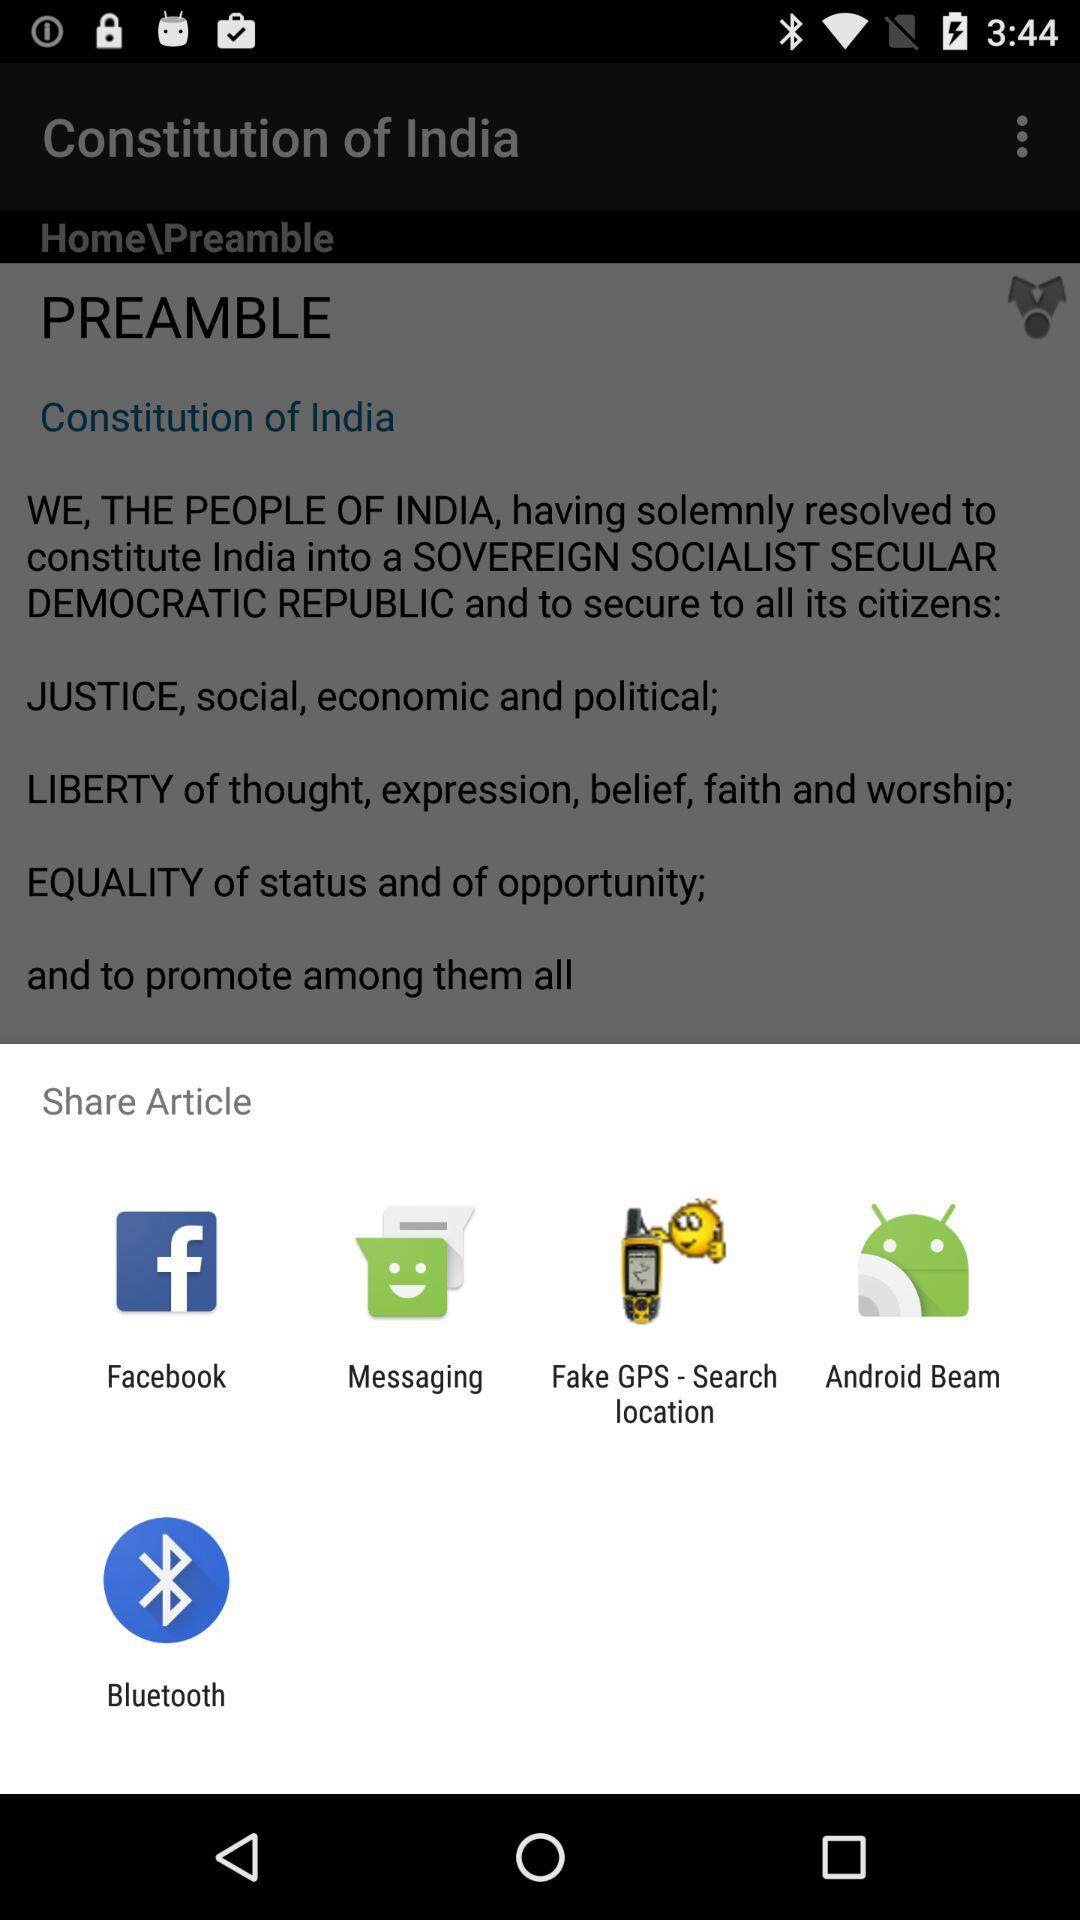What are the different applications through which we can share the article? The different applications are "Facebook", "Messaging", "Fake GPS - Search location", "Android Beam" and "Bluetooth". 